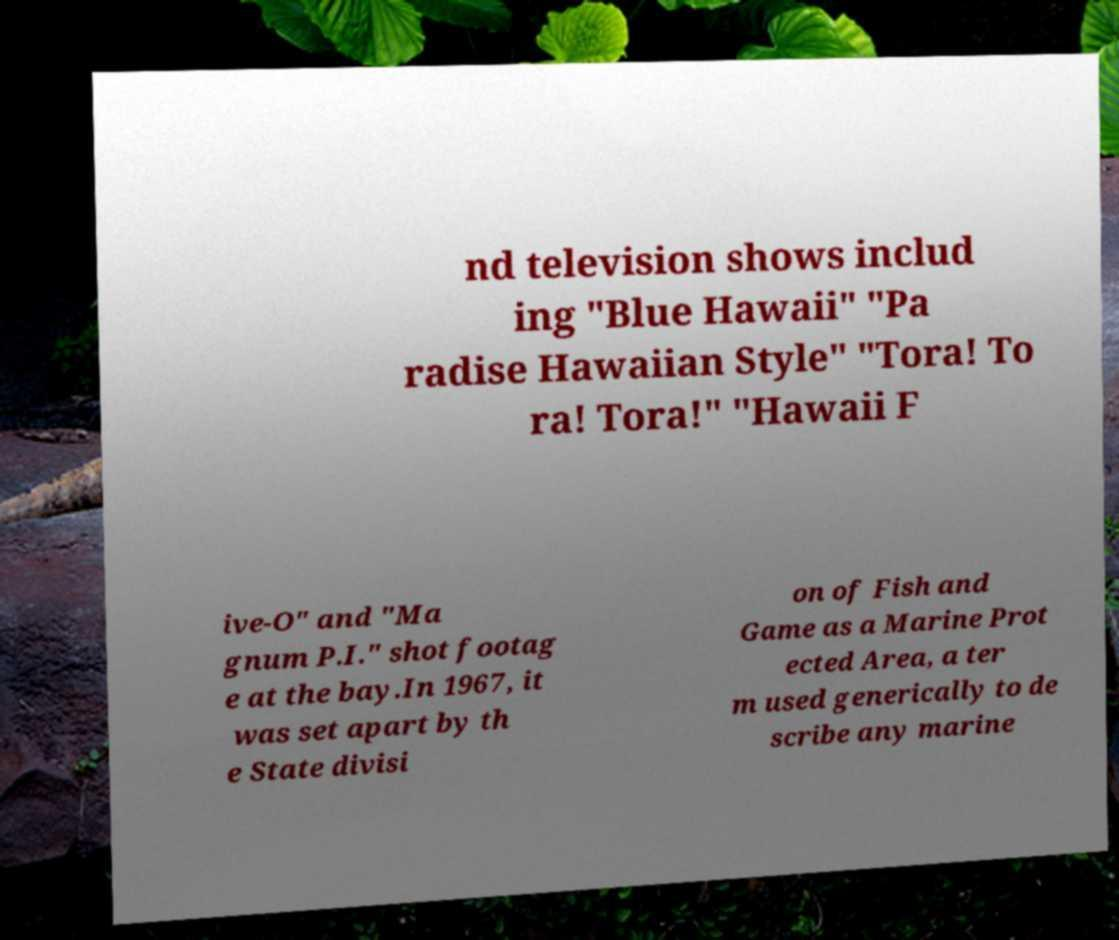Please read and relay the text visible in this image. What does it say? nd television shows includ ing "Blue Hawaii" "Pa radise Hawaiian Style" "Tora! To ra! Tora!" "Hawaii F ive-O" and "Ma gnum P.I." shot footag e at the bay.In 1967, it was set apart by th e State divisi on of Fish and Game as a Marine Prot ected Area, a ter m used generically to de scribe any marine 